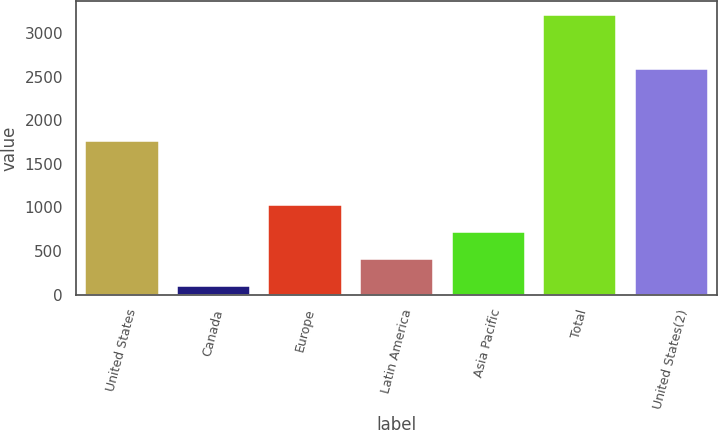Convert chart to OTSL. <chart><loc_0><loc_0><loc_500><loc_500><bar_chart><fcel>United States<fcel>Canada<fcel>Europe<fcel>Latin America<fcel>Asia Pacific<fcel>Total<fcel>United States(2)<nl><fcel>1758.8<fcel>100.8<fcel>1031.85<fcel>411.15<fcel>721.5<fcel>3204.3<fcel>2589.1<nl></chart> 